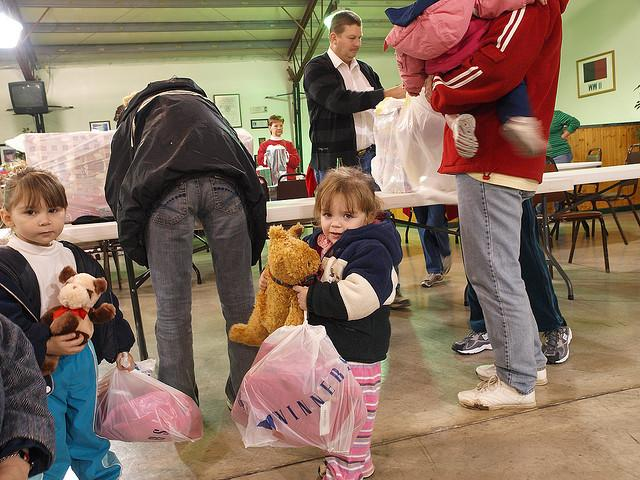What are the two girls in front doing? holding toys 